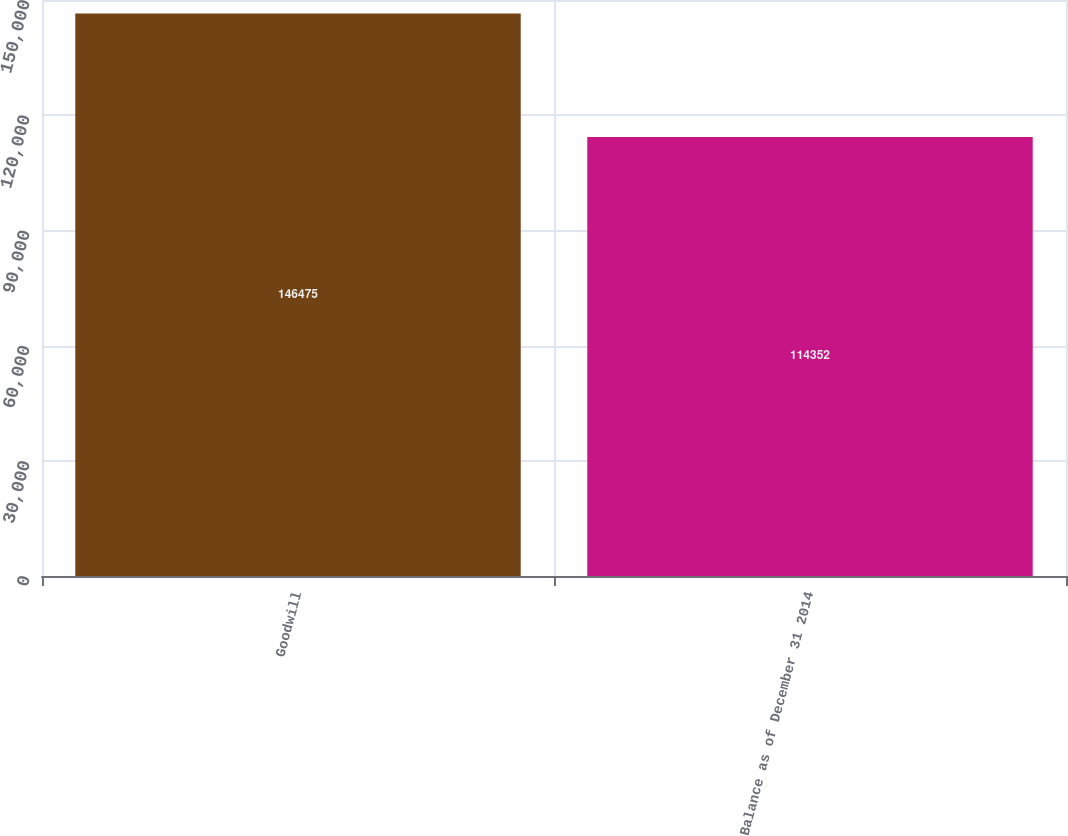Convert chart. <chart><loc_0><loc_0><loc_500><loc_500><bar_chart><fcel>Goodwill<fcel>Balance as of December 31 2014<nl><fcel>146475<fcel>114352<nl></chart> 